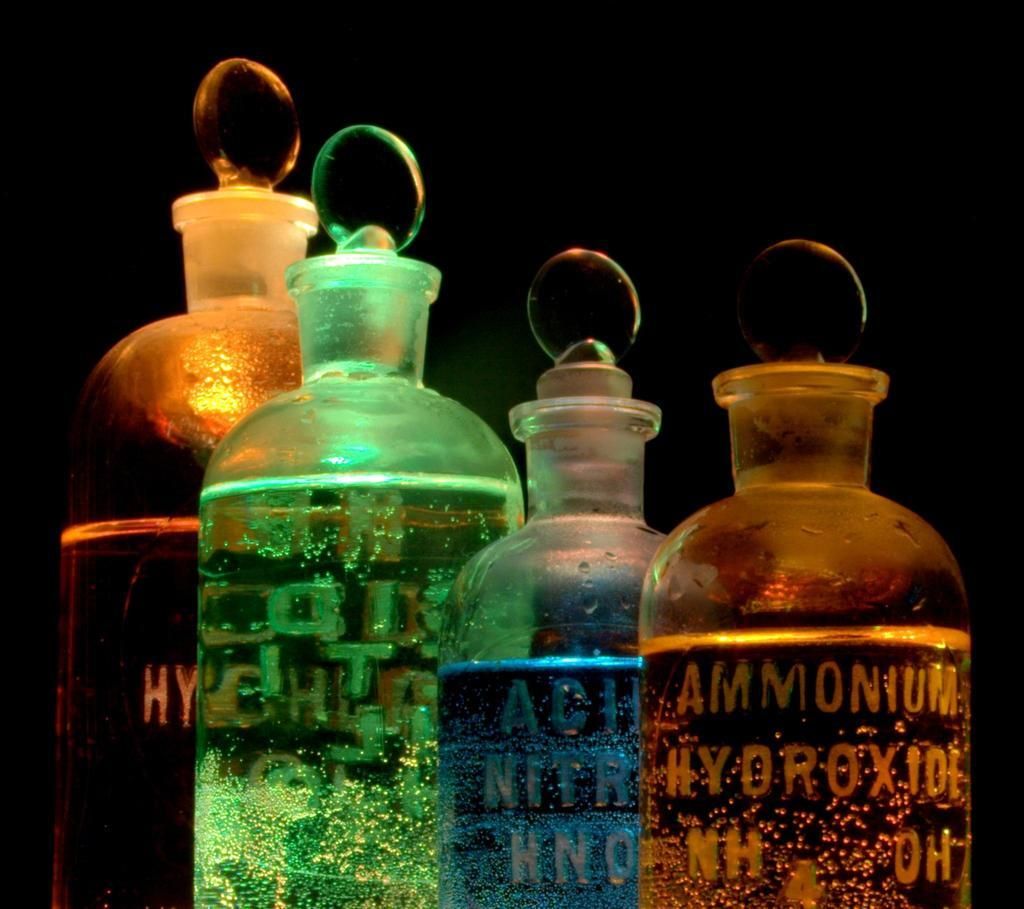Provide a one-sentence caption for the provided image. A yellow bottle has "Ammonium" sketched on the side next to a blue bottle. 